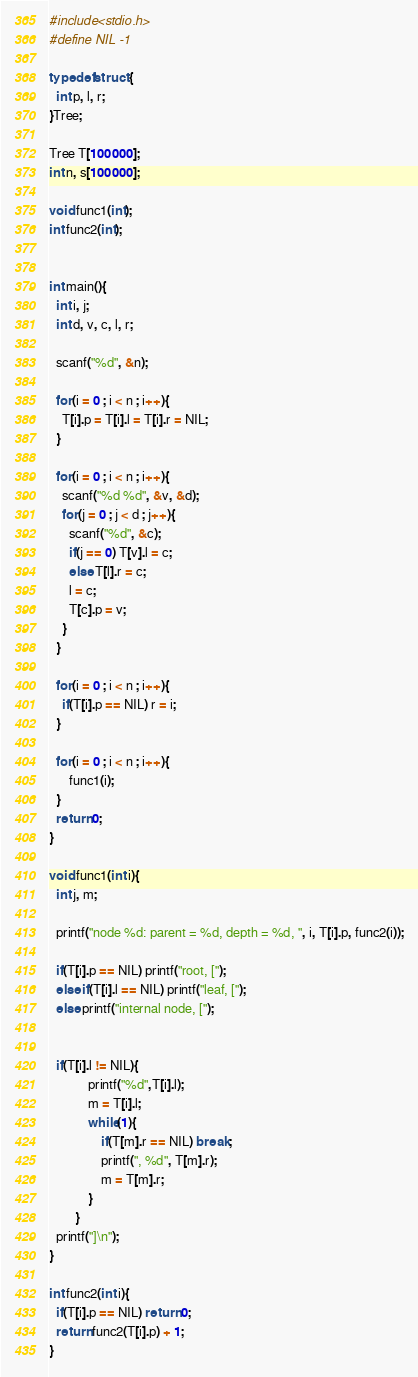Convert code to text. <code><loc_0><loc_0><loc_500><loc_500><_C_>#include<stdio.h>
#define NIL -1

typedef struct {
  int p, l, r;
}Tree;

Tree T[100000];
int n, s[100000];

void func1(int);
int func2(int);


int main(){
  int i, j;
  int d, v, c, l, r;

  scanf("%d", &n);

  for(i = 0 ; i < n ; i++){
    T[i].p = T[i].l = T[i].r = NIL;
  }

  for(i = 0 ; i < n ; i++){
    scanf("%d %d", &v, &d);
    for(j = 0 ; j < d ; j++){
      scanf("%d", &c);
      if(j == 0) T[v].l = c;
      else T[l].r = c;
      l = c;
      T[c].p = v;
    }
  }

  for(i = 0 ; i < n ; i++){
    if(T[i].p == NIL) r = i;
  }

  for(i = 0 ; i < n ; i++){
      func1(i);
  }
  return 0;
}

void func1(int i){
  int j, m;

  printf("node %d: parent = %d, depth = %d, ", i, T[i].p, func2(i));

  if(T[i].p == NIL) printf("root, [");
  else if(T[i].l == NIL) printf("leaf, [");
  else printf("internal node, [");


  if(T[i].l != NIL){
            printf("%d",T[i].l);
            m = T[i].l;
            while(1){
                if(T[m].r == NIL) break;
                printf(", %d", T[m].r);
                m = T[m].r;
            }
        }
  printf("]\n");
}

int func2(int i){
  if(T[i].p == NIL) return 0;
  return func2(T[i].p) + 1;
}

</code> 